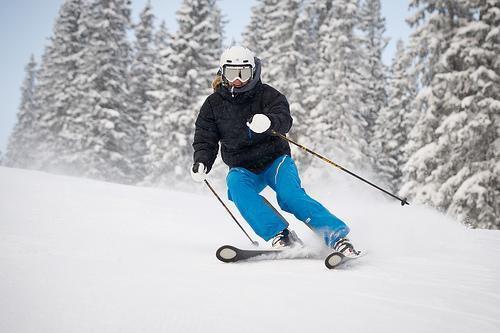How many skiers are visible?
Give a very brief answer. 1. How many people are pictured here?
Give a very brief answer. 1. How many poles are touching the ground?
Give a very brief answer. 1. 